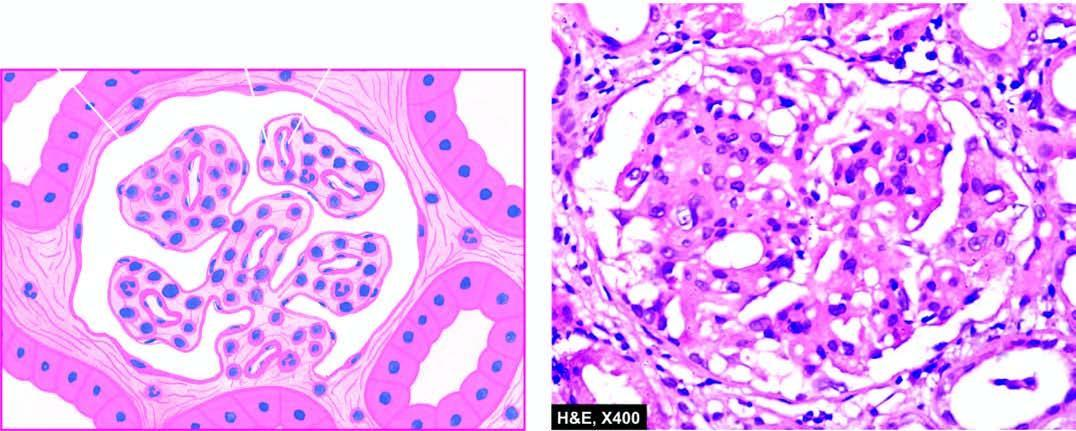what is there in the mesangial matrix between the capillaries?
Answer the question using a single word or phrase. Increase 